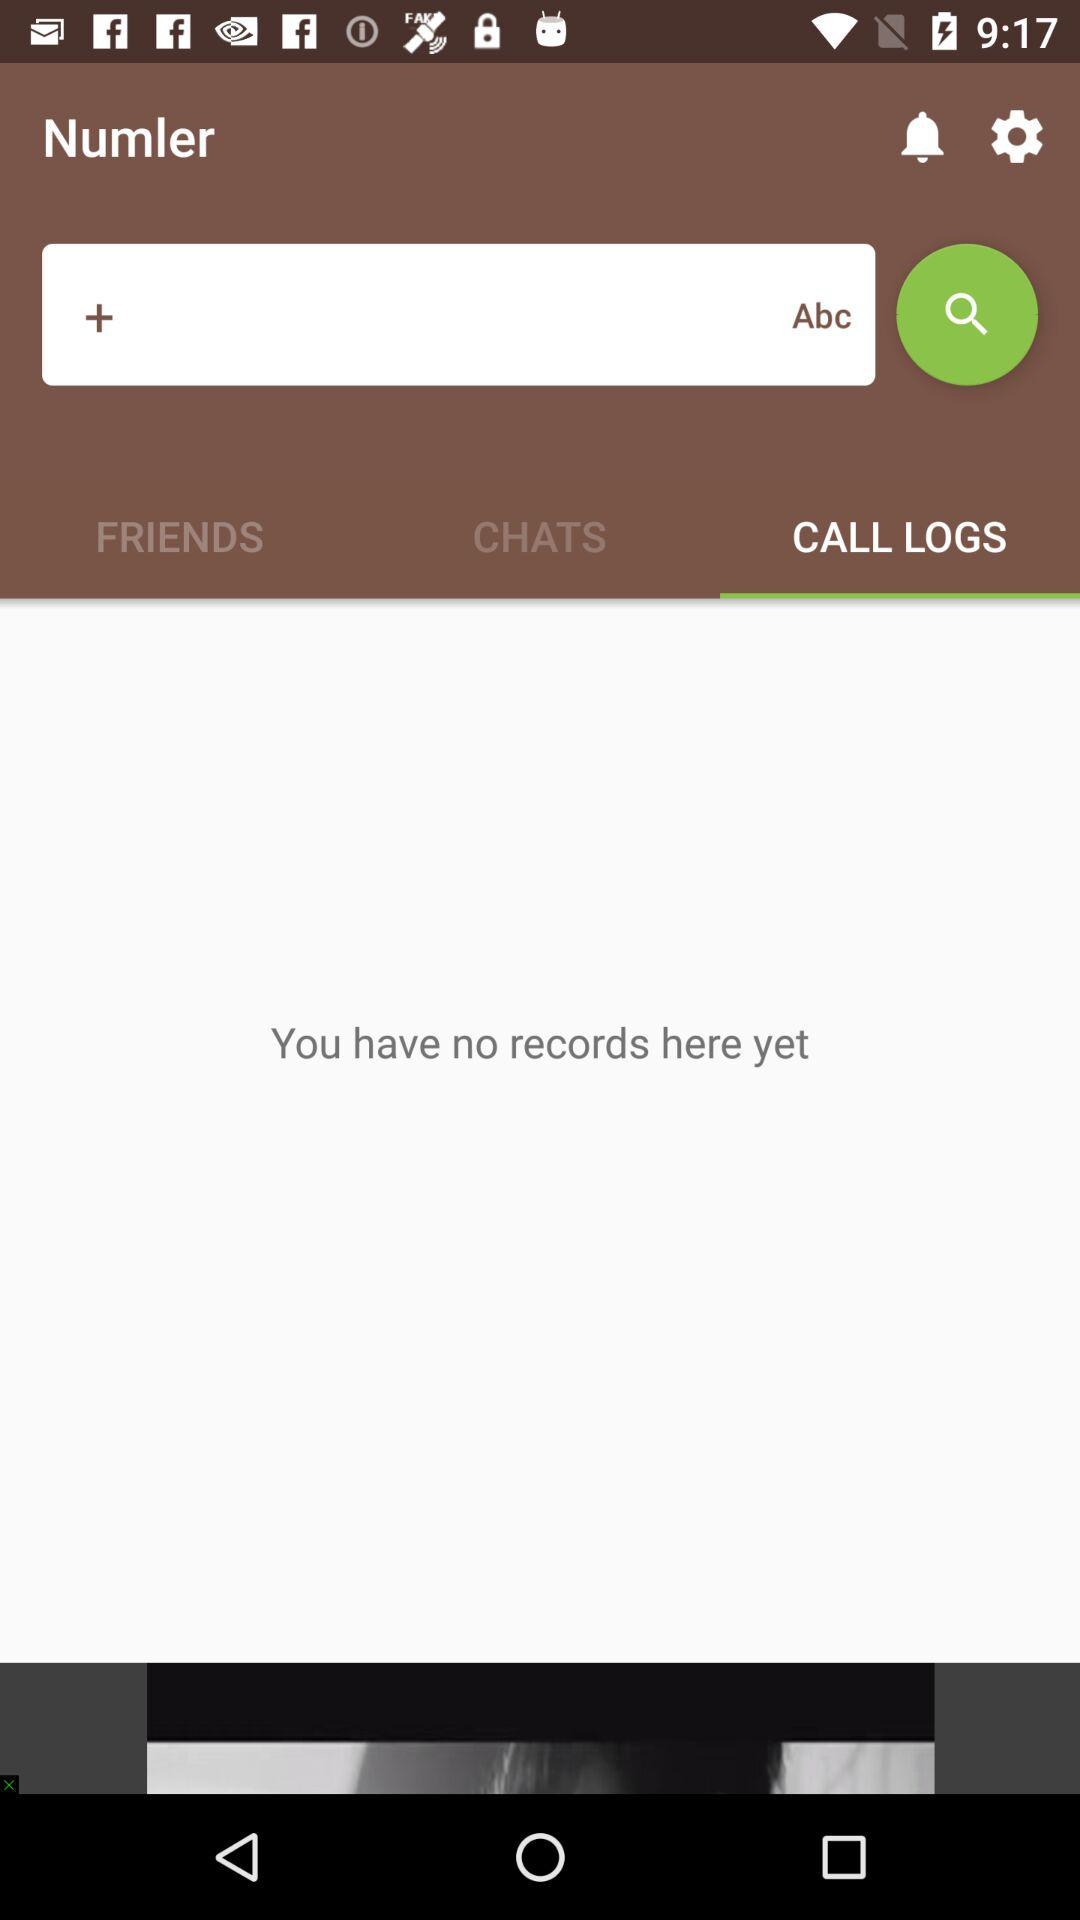Is there any call logs? There is no call logs. 